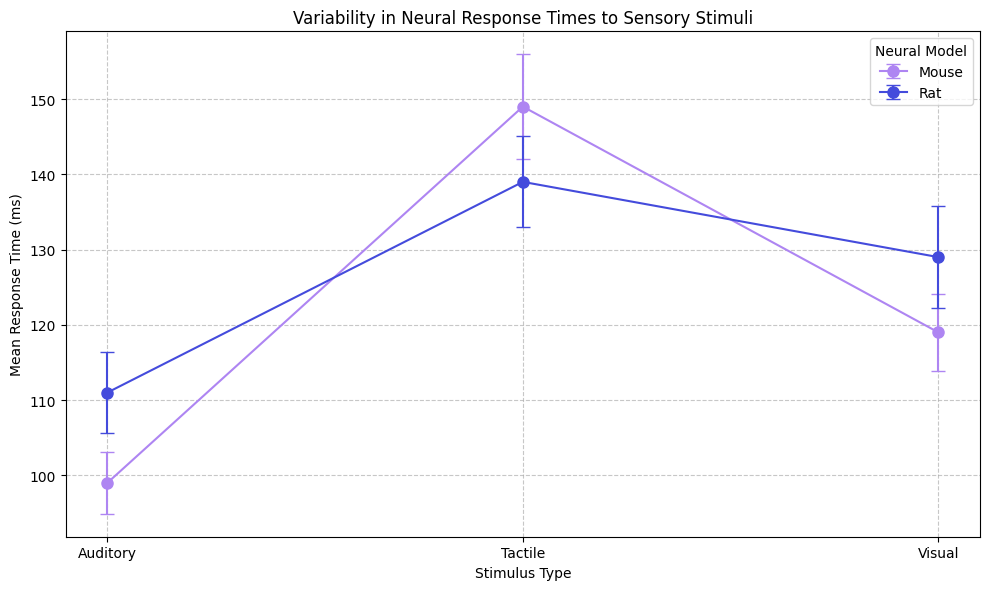What is the difference in mean response times to visual stimuli between mice and rats? The figure shows the mean response times for each stimulus type and animal model. For visual stimuli, mice have a mean response time of 119 ms, and rats have a mean response time of 129 ms. The difference is 129 - 119 = 10 ms.
Answer: 10 ms Which neural model has the highest variability in tactile response times? The variability is indicated by the error bars' length. Examining the tactile response times, mice have larger error bars compared to rats. Thus, mice have higher variability in tactile response times.
Answer: Mice In the figure, which stimulus type shows the smallest difference in mean response time between mice and rats? The difference between the mean response times of mice and rats for each stimulus type needs to be evaluated. For visual, the difference is 10 ms; for auditory, it is 14 ms; for tactile, it is 10 ms. The smallest difference is in the visual and tactile stimuli, tied at 10 ms.
Answer: Visual and Tactile For which stimulus type do rats show a higher mean response time compared to mice? By comparing the mean response times for each stimulus type, rats have higher mean response times for visual (129 vs. 119 ms) and auditory (111 vs. 99 ms) stimuli than mice. For tactile stimuli, rats have a shorter mean response time (139 vs. 149 ms).
Answer: Visual and Auditory What is the overall average response time for mice across all stimuli? The mean response times for mice are 119 ms (visual), 99 ms (auditory), and 149 ms (tactile). The overall average is calculated as (119 + 99 + 149) / 3 = 367 / 3 ≈ 122.33 ms.
Answer: ≈ 122.33 ms Are the mean response times to auditory stimuli for rats within the error bars of mice's response times to auditory stimuli? The figure shows the mean response time of 99 ms for mice with error bars extending ±4.15 ms. Thus, the range is 94.85 to 103.15 ms. For rats, the mean is 111 ms which is outside this range.
Answer: No Which stimulus type demonstrates the most significant mean response time difference between two neural models? Calculate the differences in mean response times for each stimulus type: visual (10 ms), auditory (14 ms), and tactile (10 ms). The auditory stimulus has the most considerable difference.
Answer: Auditory Among the stimuli, which has the highest overall mean response time across both neural models? By averaging the mean response times of both models for each stimulus type: visual (124 ms), auditory (105 ms), and tactile (144 ms), tactile stimuli have the highest overall mean response time.
Answer: Tactile Which stimulus type shows the smallest error bars overall? Error bars representing standard deviations need to be compared. Visual inspection shows that auditory stimuli have the shortest error bars across both models.
Answer: Auditory What is the average standard deviation in response times for rats across all stimulus types? The standard deviation values for rats are obtained from visual (6.75 ms), auditory (5.4 ms), and tactile (6.05 ms). The average is (6.75 + 5.4 + 6.05) / 3 = 18.2 / 3 ≈ 6.07 ms.
Answer: ≈ 6.07 ms 